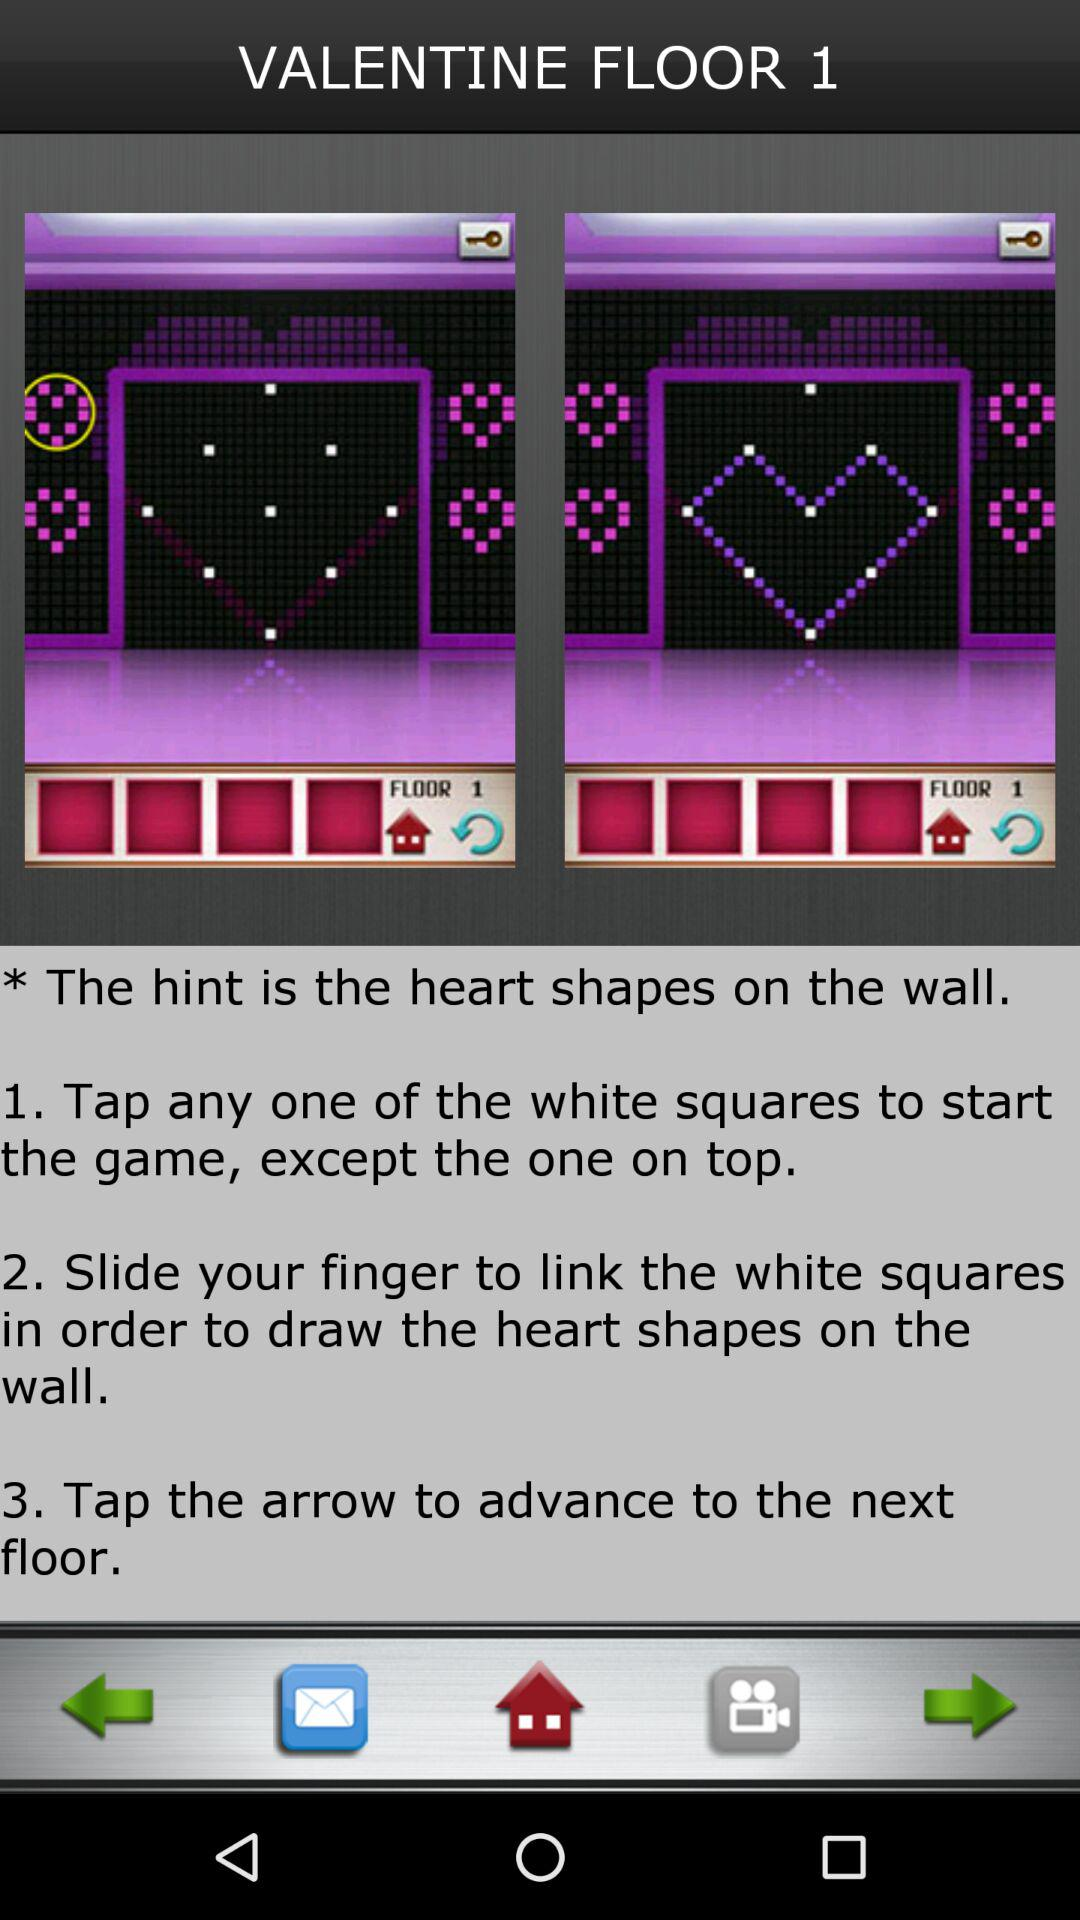How many steps are there in the hint?
Answer the question using a single word or phrase. 3 